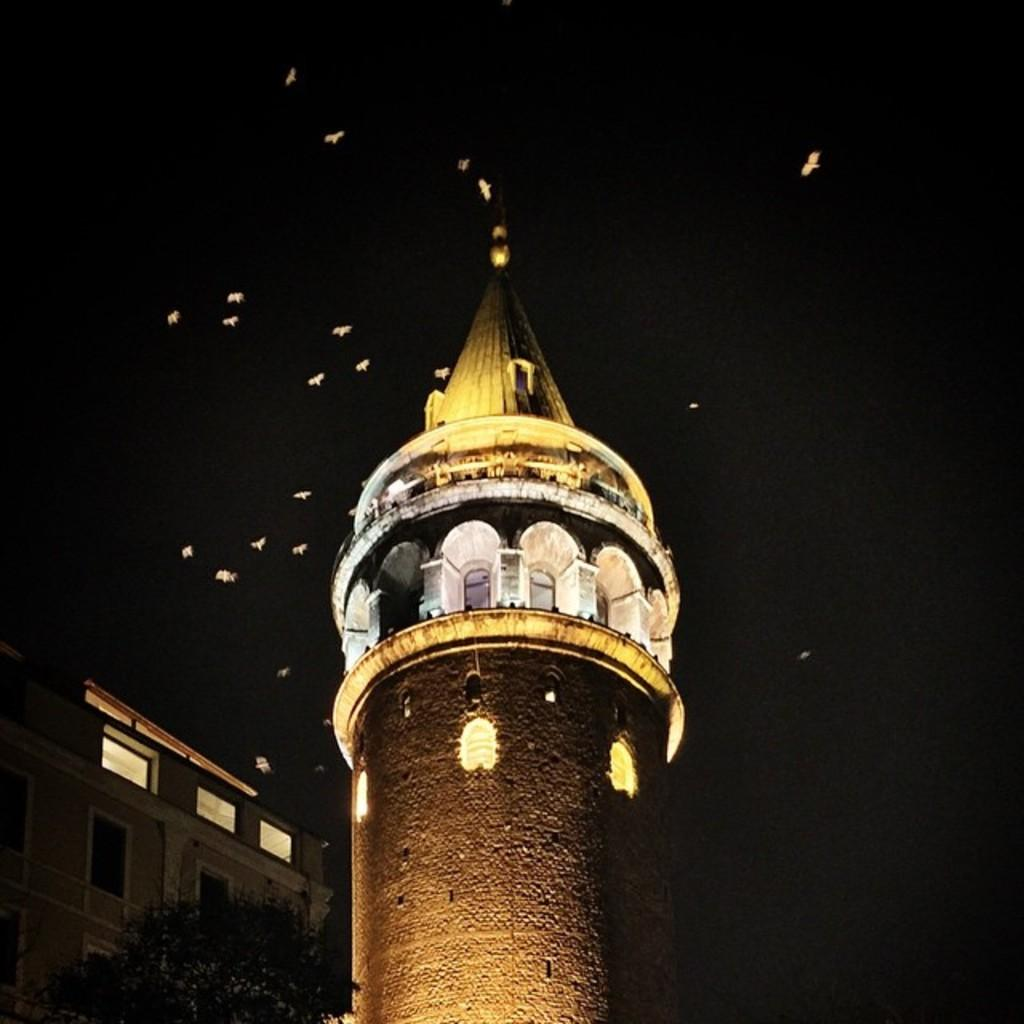What is the lighting condition in the image? The image is taken in the dark. What is the main structure featured in the image? There is a tower with lights in the image. What other types of structures can be seen in the image? There are buildings in the image. What type of vegetation is present in the image? There are trees in the image. What is happening in the sky in the image? Birds are flying in the dark sky in the image. What is the time of day for the attempted experience in the image? There is no attempt or experience mentioned in the image; it simply shows a dark scene with a tower, buildings, trees, and flying birds. 